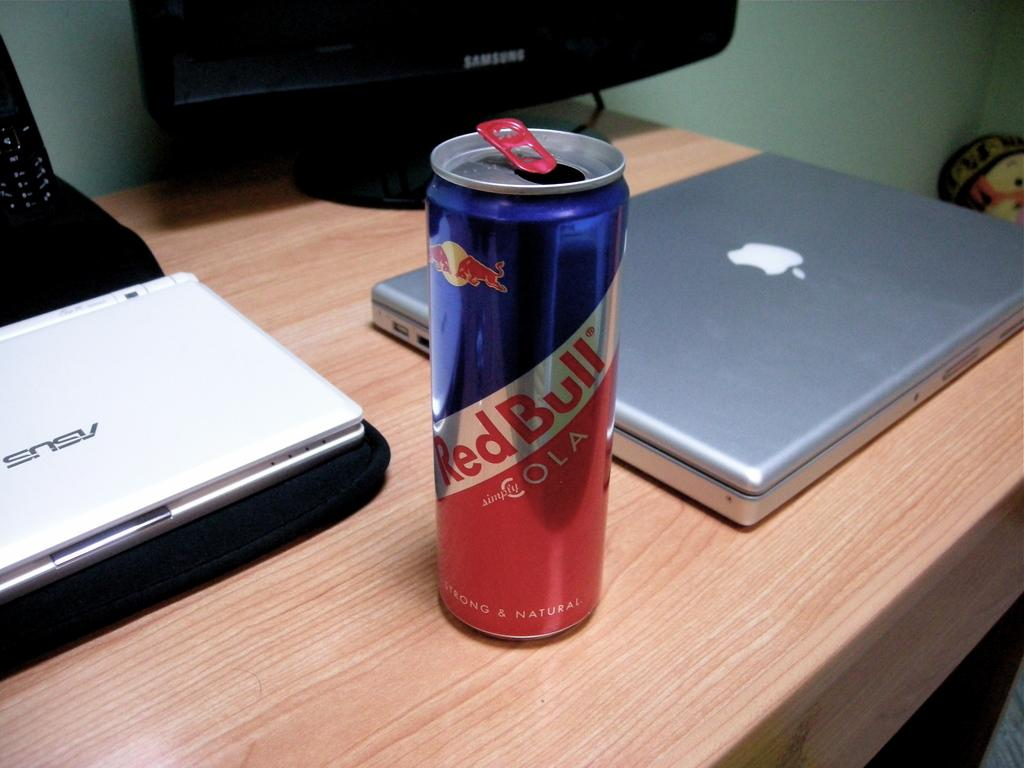<image>
Provide a brief description of the given image. A can of Red Bull on top of a desk with a Mac computer next to it. 